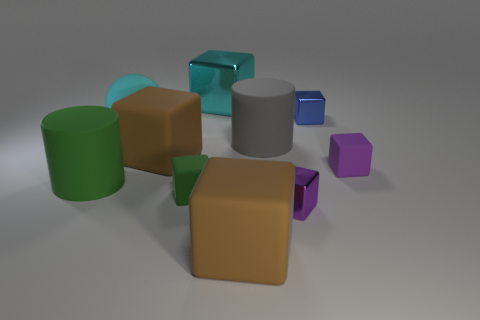Is there any other thing that has the same shape as the cyan matte object?
Your answer should be very brief. No. There is a cylinder that is in front of the brown matte thing that is on the left side of the cyan metal block; what is it made of?
Your answer should be very brief. Rubber. Are any tiny green cubes visible?
Offer a terse response. Yes. There is a metal object that is in front of the big cyan thing that is in front of the cyan block; what size is it?
Your response must be concise. Small. Is the number of large rubber things in front of the matte ball greater than the number of big shiny objects to the left of the big metallic object?
Offer a very short reply. Yes. How many blocks are tiny purple shiny things or metallic objects?
Keep it short and to the point. 3. There is a tiny shiny object that is behind the large cyan sphere; is its shape the same as the big cyan metallic object?
Your response must be concise. Yes. The rubber sphere is what color?
Give a very brief answer. Cyan. The other large metal object that is the same shape as the blue thing is what color?
Your answer should be very brief. Cyan. How many small blue metallic things have the same shape as the large cyan metal object?
Offer a very short reply. 1. 